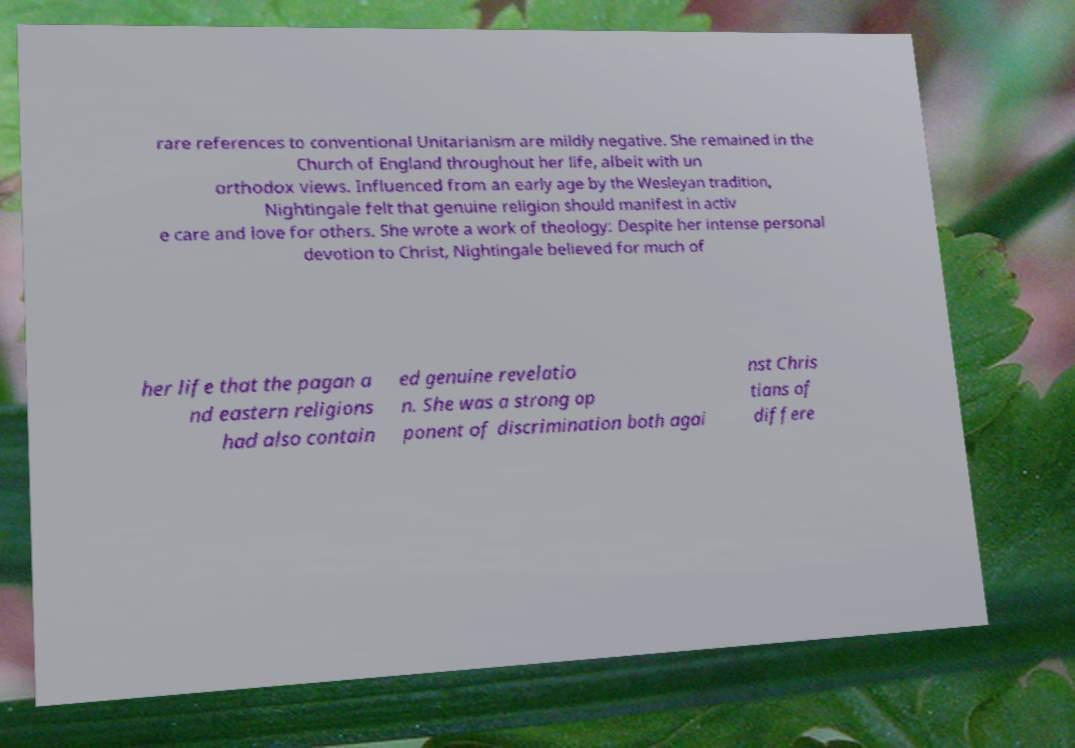Please read and relay the text visible in this image. What does it say? rare references to conventional Unitarianism are mildly negative. She remained in the Church of England throughout her life, albeit with un orthodox views. Influenced from an early age by the Wesleyan tradition, Nightingale felt that genuine religion should manifest in activ e care and love for others. She wrote a work of theology: Despite her intense personal devotion to Christ, Nightingale believed for much of her life that the pagan a nd eastern religions had also contain ed genuine revelatio n. She was a strong op ponent of discrimination both agai nst Chris tians of differe 